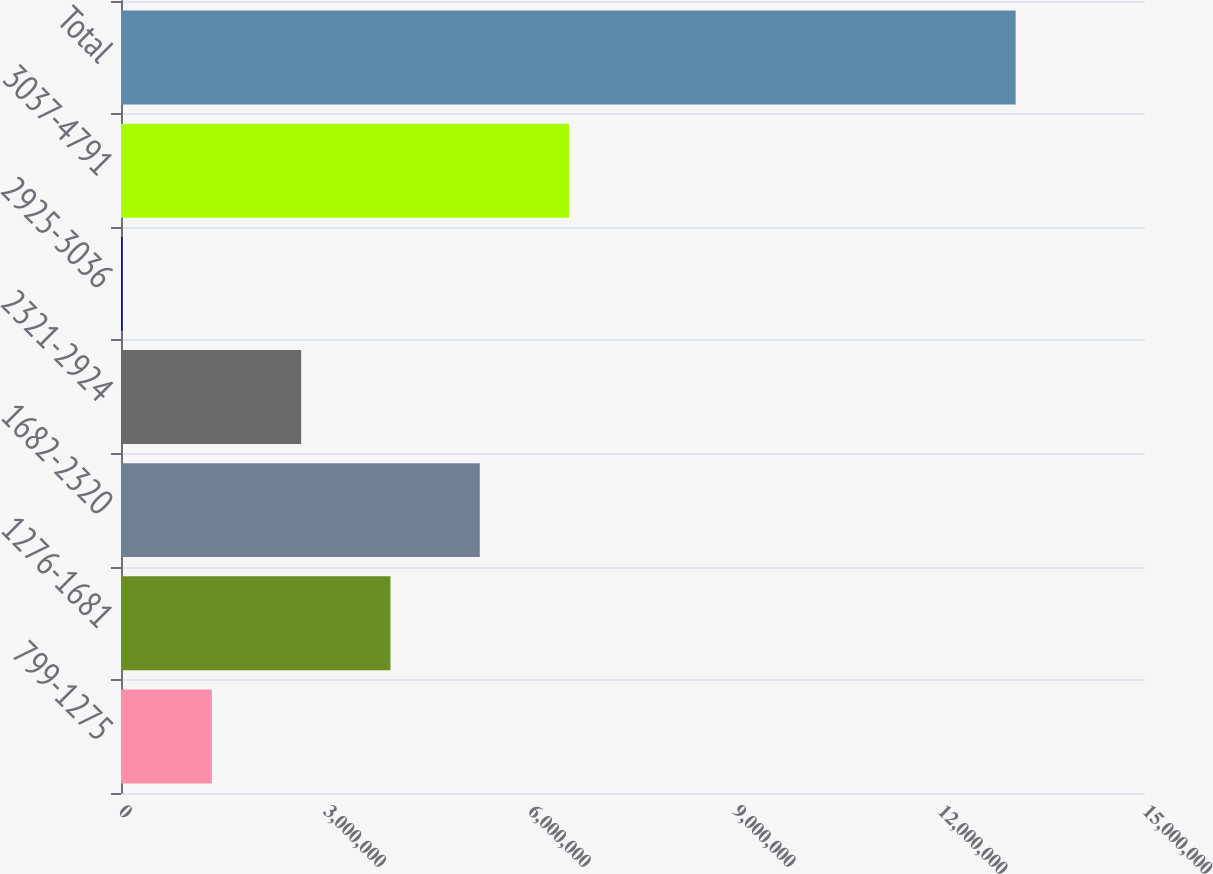<chart> <loc_0><loc_0><loc_500><loc_500><bar_chart><fcel>799-1275<fcel>1276-1681<fcel>1682-2320<fcel>2321-2924<fcel>2925-3036<fcel>3037-4791<fcel>Total<nl><fcel>1.3307e+06<fcel>3.94731e+06<fcel>5.25562e+06<fcel>2.639e+06<fcel>22388<fcel>6.56392e+06<fcel>1.31055e+07<nl></chart> 